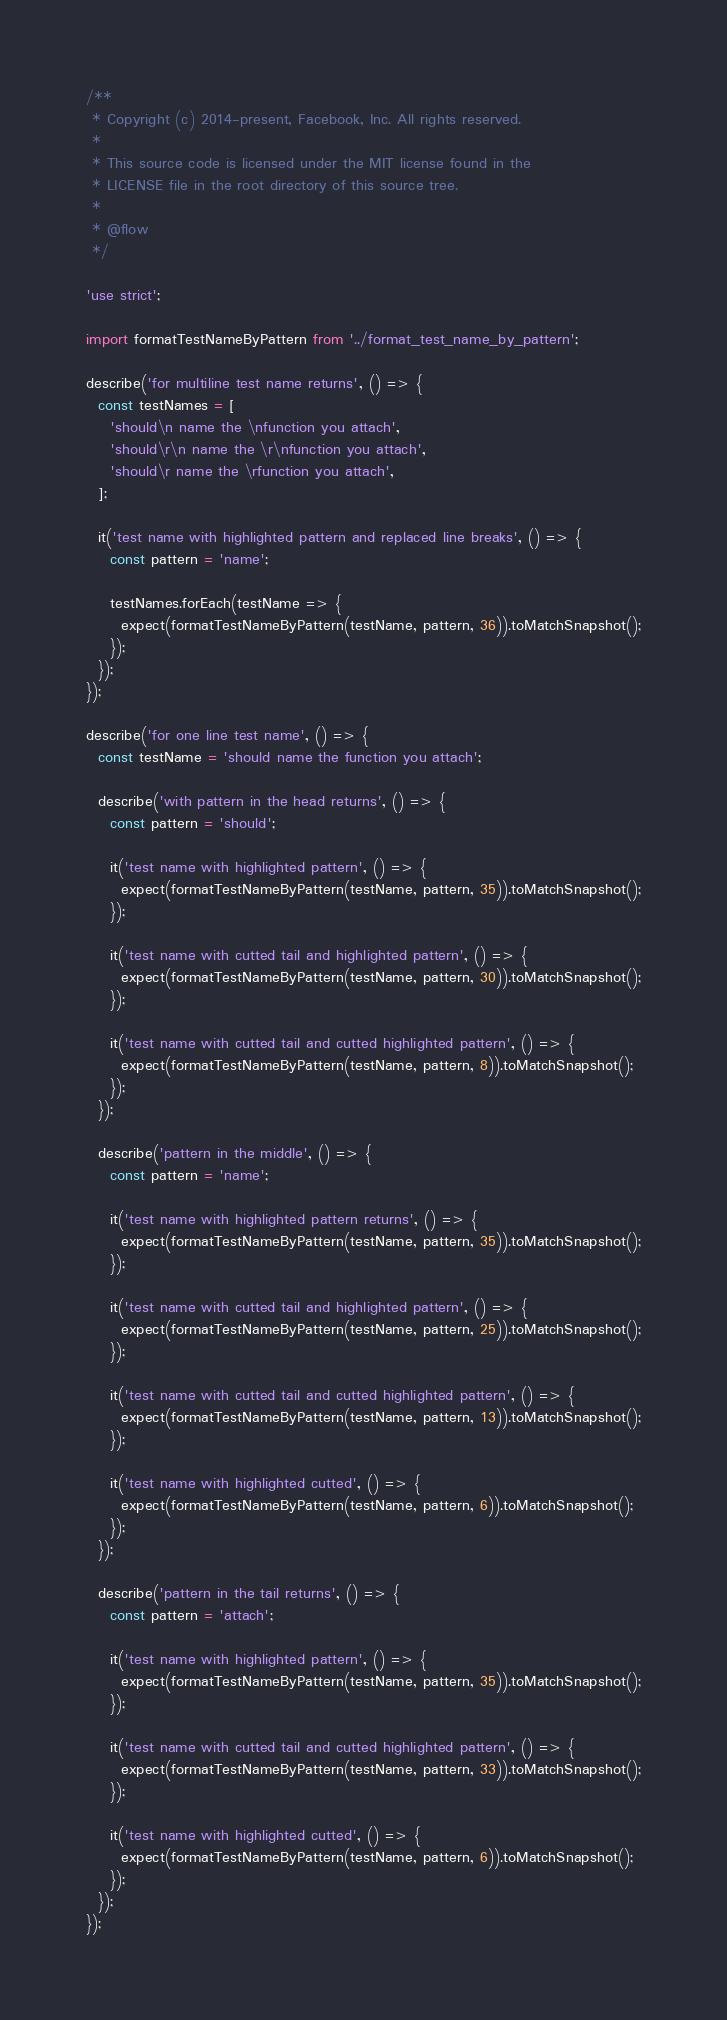<code> <loc_0><loc_0><loc_500><loc_500><_JavaScript_>/**
 * Copyright (c) 2014-present, Facebook, Inc. All rights reserved.
 *
 * This source code is licensed under the MIT license found in the
 * LICENSE file in the root directory of this source tree.
 *
 * @flow
 */

'use strict';

import formatTestNameByPattern from '../format_test_name_by_pattern';

describe('for multiline test name returns', () => {
  const testNames = [
    'should\n name the \nfunction you attach',
    'should\r\n name the \r\nfunction you attach',
    'should\r name the \rfunction you attach',
  ];

  it('test name with highlighted pattern and replaced line breaks', () => {
    const pattern = 'name';

    testNames.forEach(testName => {
      expect(formatTestNameByPattern(testName, pattern, 36)).toMatchSnapshot();
    });
  });
});

describe('for one line test name', () => {
  const testName = 'should name the function you attach';

  describe('with pattern in the head returns', () => {
    const pattern = 'should';

    it('test name with highlighted pattern', () => {
      expect(formatTestNameByPattern(testName, pattern, 35)).toMatchSnapshot();
    });

    it('test name with cutted tail and highlighted pattern', () => {
      expect(formatTestNameByPattern(testName, pattern, 30)).toMatchSnapshot();
    });

    it('test name with cutted tail and cutted highlighted pattern', () => {
      expect(formatTestNameByPattern(testName, pattern, 8)).toMatchSnapshot();
    });
  });

  describe('pattern in the middle', () => {
    const pattern = 'name';

    it('test name with highlighted pattern returns', () => {
      expect(formatTestNameByPattern(testName, pattern, 35)).toMatchSnapshot();
    });

    it('test name with cutted tail and highlighted pattern', () => {
      expect(formatTestNameByPattern(testName, pattern, 25)).toMatchSnapshot();
    });

    it('test name with cutted tail and cutted highlighted pattern', () => {
      expect(formatTestNameByPattern(testName, pattern, 13)).toMatchSnapshot();
    });

    it('test name with highlighted cutted', () => {
      expect(formatTestNameByPattern(testName, pattern, 6)).toMatchSnapshot();
    });
  });

  describe('pattern in the tail returns', () => {
    const pattern = 'attach';

    it('test name with highlighted pattern', () => {
      expect(formatTestNameByPattern(testName, pattern, 35)).toMatchSnapshot();
    });

    it('test name with cutted tail and cutted highlighted pattern', () => {
      expect(formatTestNameByPattern(testName, pattern, 33)).toMatchSnapshot();
    });

    it('test name with highlighted cutted', () => {
      expect(formatTestNameByPattern(testName, pattern, 6)).toMatchSnapshot();
    });
  });
});
</code> 